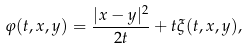Convert formula to latex. <formula><loc_0><loc_0><loc_500><loc_500>\varphi ( t , x , y ) = \frac { | x - y | ^ { 2 } } { 2 t } + t \xi ( t , x , y ) ,</formula> 